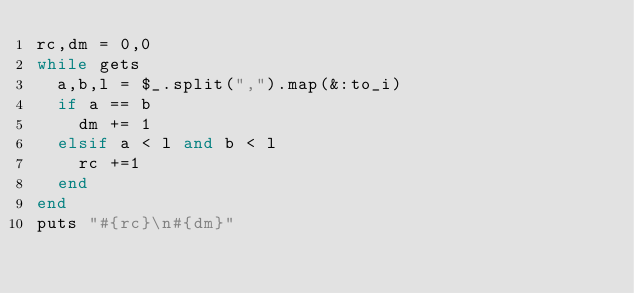<code> <loc_0><loc_0><loc_500><loc_500><_Ruby_>rc,dm = 0,0
while gets
  a,b,l = $_.split(",").map(&:to_i)
  if a == b
    dm += 1 
  elsif a < l and b < l
    rc +=1
  end
end
puts "#{rc}\n#{dm}"</code> 